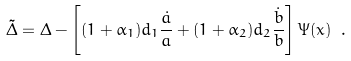<formula> <loc_0><loc_0><loc_500><loc_500>\tilde { \Delta } = \Delta - \left [ ( 1 + \alpha _ { 1 } ) d _ { 1 } \frac { \dot { a } } { a } + ( 1 + \alpha _ { 2 } ) d _ { 2 } \frac { \dot { b } } { b } \right ] \Psi ( x ) \ .</formula> 